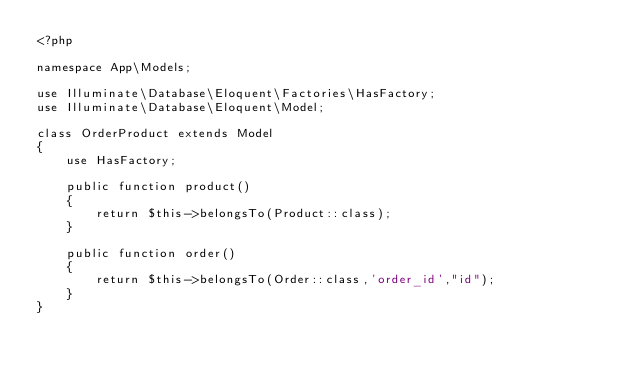Convert code to text. <code><loc_0><loc_0><loc_500><loc_500><_PHP_><?php

namespace App\Models;

use Illuminate\Database\Eloquent\Factories\HasFactory;
use Illuminate\Database\Eloquent\Model;

class OrderProduct extends Model
{
    use HasFactory;

    public function product()
    {
        return $this->belongsTo(Product::class);
    }

    public function order()
    {
        return $this->belongsTo(Order::class,'order_id',"id");
    }
}
</code> 